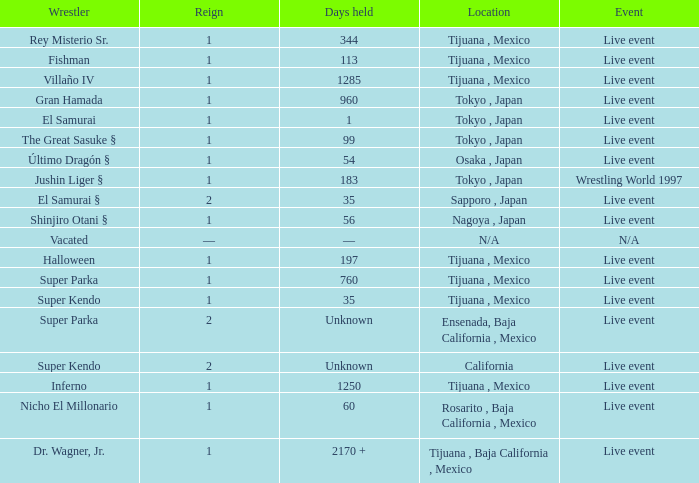Where did the wrestler, super parka, with the title with a reign of 2? Ensenada, Baja California , Mexico. Parse the table in full. {'header': ['Wrestler', 'Reign', 'Days held', 'Location', 'Event'], 'rows': [['Rey Misterio Sr.', '1', '344', 'Tijuana , Mexico', 'Live event'], ['Fishman', '1', '113', 'Tijuana , Mexico', 'Live event'], ['Villaño IV', '1', '1285', 'Tijuana , Mexico', 'Live event'], ['Gran Hamada', '1', '960', 'Tokyo , Japan', 'Live event'], ['El Samurai', '1', '1', 'Tokyo , Japan', 'Live event'], ['The Great Sasuke §', '1', '99', 'Tokyo , Japan', 'Live event'], ['Último Dragón §', '1', '54', 'Osaka , Japan', 'Live event'], ['Jushin Liger §', '1', '183', 'Tokyo , Japan', 'Wrestling World 1997'], ['El Samurai §', '2', '35', 'Sapporo , Japan', 'Live event'], ['Shinjiro Otani §', '1', '56', 'Nagoya , Japan', 'Live event'], ['Vacated', '—', '—', 'N/A', 'N/A'], ['Halloween', '1', '197', 'Tijuana , Mexico', 'Live event'], ['Super Parka', '1', '760', 'Tijuana , Mexico', 'Live event'], ['Super Kendo', '1', '35', 'Tijuana , Mexico', 'Live event'], ['Super Parka', '2', 'Unknown', 'Ensenada, Baja California , Mexico', 'Live event'], ['Super Kendo', '2', 'Unknown', 'California', 'Live event'], ['Inferno', '1', '1250', 'Tijuana , Mexico', 'Live event'], ['Nicho El Millonario', '1', '60', 'Rosarito , Baja California , Mexico', 'Live event'], ['Dr. Wagner, Jr.', '1', '2170 +', 'Tijuana , Baja California , Mexico', 'Live event']]} 